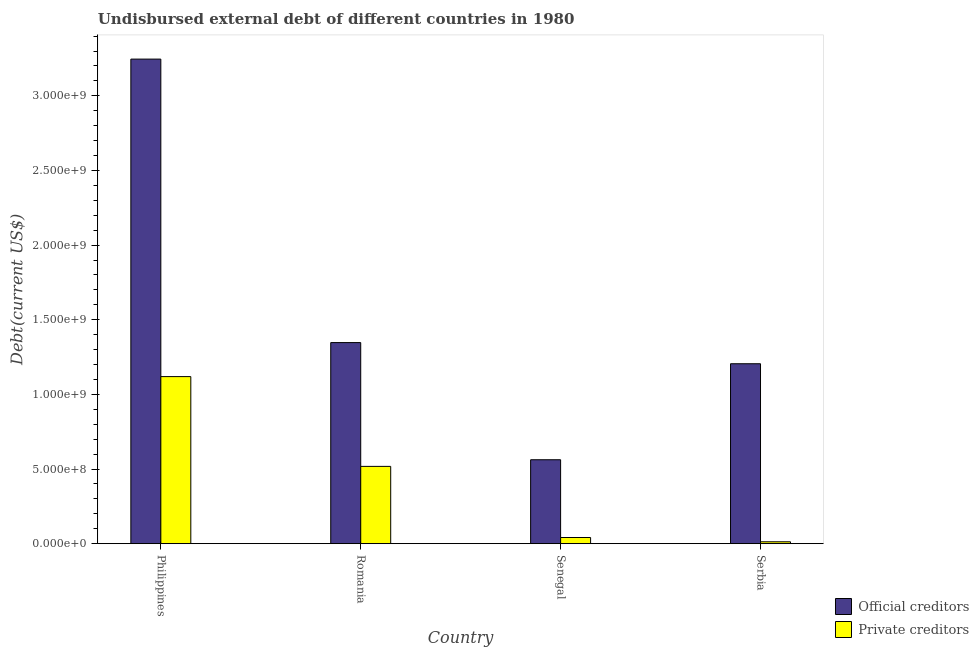What is the label of the 4th group of bars from the left?
Provide a succinct answer. Serbia. In how many cases, is the number of bars for a given country not equal to the number of legend labels?
Your response must be concise. 0. What is the undisbursed external debt of private creditors in Serbia?
Make the answer very short. 1.25e+07. Across all countries, what is the maximum undisbursed external debt of private creditors?
Ensure brevity in your answer.  1.12e+09. Across all countries, what is the minimum undisbursed external debt of official creditors?
Provide a succinct answer. 5.62e+08. In which country was the undisbursed external debt of private creditors minimum?
Your answer should be compact. Serbia. What is the total undisbursed external debt of private creditors in the graph?
Your answer should be very brief. 1.69e+09. What is the difference between the undisbursed external debt of official creditors in Senegal and that in Serbia?
Your response must be concise. -6.43e+08. What is the difference between the undisbursed external debt of official creditors in Philippines and the undisbursed external debt of private creditors in Romania?
Your response must be concise. 2.73e+09. What is the average undisbursed external debt of official creditors per country?
Keep it short and to the point. 1.59e+09. What is the difference between the undisbursed external debt of official creditors and undisbursed external debt of private creditors in Senegal?
Your answer should be very brief. 5.21e+08. In how many countries, is the undisbursed external debt of private creditors greater than 3100000000 US$?
Your response must be concise. 0. What is the ratio of the undisbursed external debt of official creditors in Philippines to that in Serbia?
Keep it short and to the point. 2.69. What is the difference between the highest and the second highest undisbursed external debt of official creditors?
Provide a succinct answer. 1.90e+09. What is the difference between the highest and the lowest undisbursed external debt of private creditors?
Provide a succinct answer. 1.11e+09. In how many countries, is the undisbursed external debt of private creditors greater than the average undisbursed external debt of private creditors taken over all countries?
Your answer should be very brief. 2. What does the 2nd bar from the left in Philippines represents?
Ensure brevity in your answer.  Private creditors. What does the 1st bar from the right in Philippines represents?
Provide a succinct answer. Private creditors. What is the difference between two consecutive major ticks on the Y-axis?
Your answer should be compact. 5.00e+08. Does the graph contain any zero values?
Your answer should be compact. No. Does the graph contain grids?
Provide a succinct answer. No. How many legend labels are there?
Give a very brief answer. 2. What is the title of the graph?
Provide a succinct answer. Undisbursed external debt of different countries in 1980. Does "Female population" appear as one of the legend labels in the graph?
Provide a succinct answer. No. What is the label or title of the Y-axis?
Your response must be concise. Debt(current US$). What is the Debt(current US$) in Official creditors in Philippines?
Give a very brief answer. 3.25e+09. What is the Debt(current US$) in Private creditors in Philippines?
Make the answer very short. 1.12e+09. What is the Debt(current US$) of Official creditors in Romania?
Give a very brief answer. 1.35e+09. What is the Debt(current US$) in Private creditors in Romania?
Offer a very short reply. 5.18e+08. What is the Debt(current US$) of Official creditors in Senegal?
Your answer should be very brief. 5.62e+08. What is the Debt(current US$) of Private creditors in Senegal?
Make the answer very short. 4.12e+07. What is the Debt(current US$) of Official creditors in Serbia?
Give a very brief answer. 1.21e+09. What is the Debt(current US$) in Private creditors in Serbia?
Offer a very short reply. 1.25e+07. Across all countries, what is the maximum Debt(current US$) in Official creditors?
Your answer should be compact. 3.25e+09. Across all countries, what is the maximum Debt(current US$) in Private creditors?
Ensure brevity in your answer.  1.12e+09. Across all countries, what is the minimum Debt(current US$) in Official creditors?
Your response must be concise. 5.62e+08. Across all countries, what is the minimum Debt(current US$) of Private creditors?
Give a very brief answer. 1.25e+07. What is the total Debt(current US$) of Official creditors in the graph?
Your response must be concise. 6.36e+09. What is the total Debt(current US$) in Private creditors in the graph?
Offer a terse response. 1.69e+09. What is the difference between the Debt(current US$) in Official creditors in Philippines and that in Romania?
Offer a very short reply. 1.90e+09. What is the difference between the Debt(current US$) in Private creditors in Philippines and that in Romania?
Offer a very short reply. 6.01e+08. What is the difference between the Debt(current US$) of Official creditors in Philippines and that in Senegal?
Offer a terse response. 2.68e+09. What is the difference between the Debt(current US$) of Private creditors in Philippines and that in Senegal?
Offer a terse response. 1.08e+09. What is the difference between the Debt(current US$) of Official creditors in Philippines and that in Serbia?
Offer a very short reply. 2.04e+09. What is the difference between the Debt(current US$) in Private creditors in Philippines and that in Serbia?
Your answer should be compact. 1.11e+09. What is the difference between the Debt(current US$) in Official creditors in Romania and that in Senegal?
Your answer should be compact. 7.85e+08. What is the difference between the Debt(current US$) in Private creditors in Romania and that in Senegal?
Provide a short and direct response. 4.76e+08. What is the difference between the Debt(current US$) in Official creditors in Romania and that in Serbia?
Offer a very short reply. 1.42e+08. What is the difference between the Debt(current US$) of Private creditors in Romania and that in Serbia?
Your answer should be very brief. 5.05e+08. What is the difference between the Debt(current US$) of Official creditors in Senegal and that in Serbia?
Keep it short and to the point. -6.43e+08. What is the difference between the Debt(current US$) in Private creditors in Senegal and that in Serbia?
Your answer should be compact. 2.87e+07. What is the difference between the Debt(current US$) of Official creditors in Philippines and the Debt(current US$) of Private creditors in Romania?
Your answer should be compact. 2.73e+09. What is the difference between the Debt(current US$) in Official creditors in Philippines and the Debt(current US$) in Private creditors in Senegal?
Offer a terse response. 3.20e+09. What is the difference between the Debt(current US$) of Official creditors in Philippines and the Debt(current US$) of Private creditors in Serbia?
Your answer should be very brief. 3.23e+09. What is the difference between the Debt(current US$) of Official creditors in Romania and the Debt(current US$) of Private creditors in Senegal?
Provide a succinct answer. 1.31e+09. What is the difference between the Debt(current US$) in Official creditors in Romania and the Debt(current US$) in Private creditors in Serbia?
Offer a terse response. 1.33e+09. What is the difference between the Debt(current US$) of Official creditors in Senegal and the Debt(current US$) of Private creditors in Serbia?
Make the answer very short. 5.50e+08. What is the average Debt(current US$) in Official creditors per country?
Provide a short and direct response. 1.59e+09. What is the average Debt(current US$) in Private creditors per country?
Give a very brief answer. 4.23e+08. What is the difference between the Debt(current US$) in Official creditors and Debt(current US$) in Private creditors in Philippines?
Make the answer very short. 2.13e+09. What is the difference between the Debt(current US$) of Official creditors and Debt(current US$) of Private creditors in Romania?
Give a very brief answer. 8.29e+08. What is the difference between the Debt(current US$) of Official creditors and Debt(current US$) of Private creditors in Senegal?
Your answer should be very brief. 5.21e+08. What is the difference between the Debt(current US$) in Official creditors and Debt(current US$) in Private creditors in Serbia?
Your response must be concise. 1.19e+09. What is the ratio of the Debt(current US$) in Official creditors in Philippines to that in Romania?
Your answer should be very brief. 2.41. What is the ratio of the Debt(current US$) in Private creditors in Philippines to that in Romania?
Your response must be concise. 2.16. What is the ratio of the Debt(current US$) in Official creditors in Philippines to that in Senegal?
Offer a very short reply. 5.77. What is the ratio of the Debt(current US$) in Private creditors in Philippines to that in Senegal?
Your response must be concise. 27.17. What is the ratio of the Debt(current US$) in Official creditors in Philippines to that in Serbia?
Make the answer very short. 2.69. What is the ratio of the Debt(current US$) of Private creditors in Philippines to that in Serbia?
Make the answer very short. 89.35. What is the ratio of the Debt(current US$) in Official creditors in Romania to that in Senegal?
Offer a terse response. 2.4. What is the ratio of the Debt(current US$) of Private creditors in Romania to that in Senegal?
Your answer should be very brief. 12.57. What is the ratio of the Debt(current US$) of Official creditors in Romania to that in Serbia?
Give a very brief answer. 1.12. What is the ratio of the Debt(current US$) of Private creditors in Romania to that in Serbia?
Your response must be concise. 41.34. What is the ratio of the Debt(current US$) in Official creditors in Senegal to that in Serbia?
Provide a succinct answer. 0.47. What is the ratio of the Debt(current US$) of Private creditors in Senegal to that in Serbia?
Keep it short and to the point. 3.29. What is the difference between the highest and the second highest Debt(current US$) of Official creditors?
Your response must be concise. 1.90e+09. What is the difference between the highest and the second highest Debt(current US$) in Private creditors?
Your answer should be compact. 6.01e+08. What is the difference between the highest and the lowest Debt(current US$) in Official creditors?
Offer a terse response. 2.68e+09. What is the difference between the highest and the lowest Debt(current US$) in Private creditors?
Make the answer very short. 1.11e+09. 